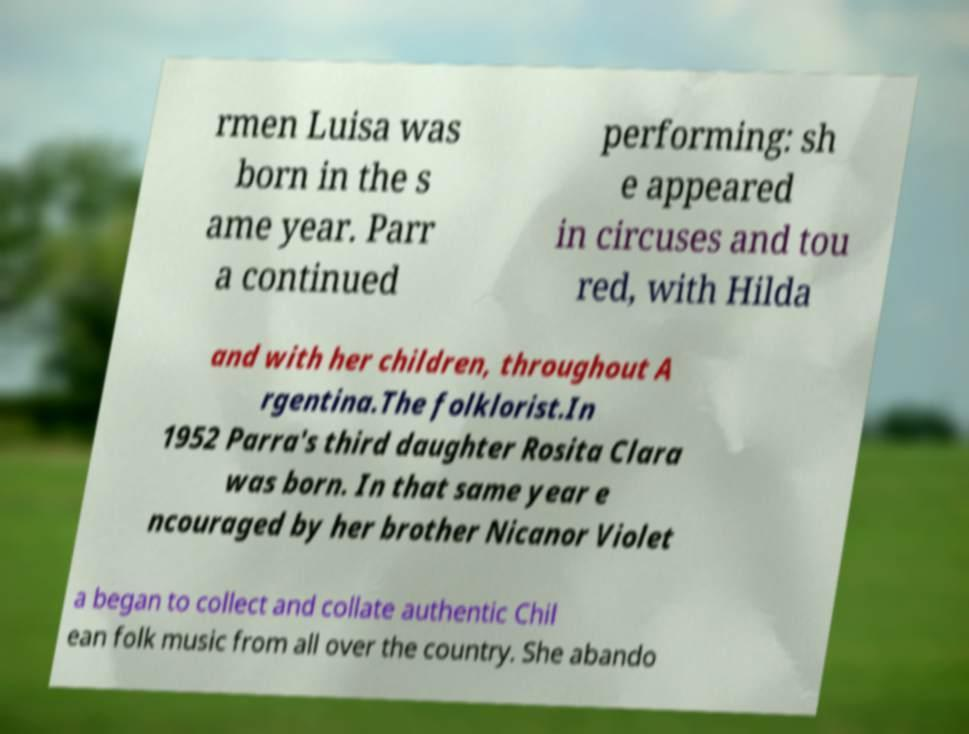Please read and relay the text visible in this image. What does it say? rmen Luisa was born in the s ame year. Parr a continued performing: sh e appeared in circuses and tou red, with Hilda and with her children, throughout A rgentina.The folklorist.In 1952 Parra's third daughter Rosita Clara was born. In that same year e ncouraged by her brother Nicanor Violet a began to collect and collate authentic Chil ean folk music from all over the country. She abando 